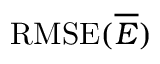<formula> <loc_0><loc_0><loc_500><loc_500>R M S E ( \overline { E } )</formula> 